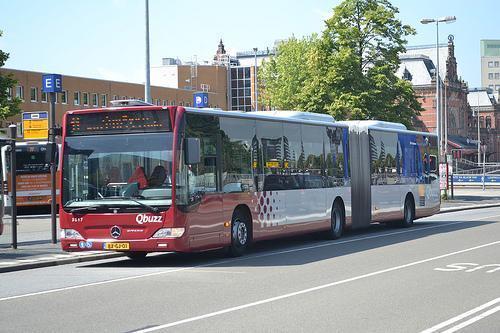How many full buses are in the photo?
Give a very brief answer. 1. How many wheels on the bus are visible?
Give a very brief answer. 3. How many buses are in the water?
Give a very brief answer. 0. 